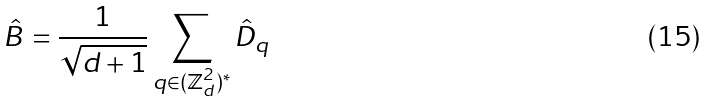<formula> <loc_0><loc_0><loc_500><loc_500>\hat { B } = \frac { 1 } { \sqrt { d + 1 } } \sum _ { q \in ( \mathbb { Z } _ { d } ^ { 2 } ) ^ { * } } \hat { D } _ { q }</formula> 